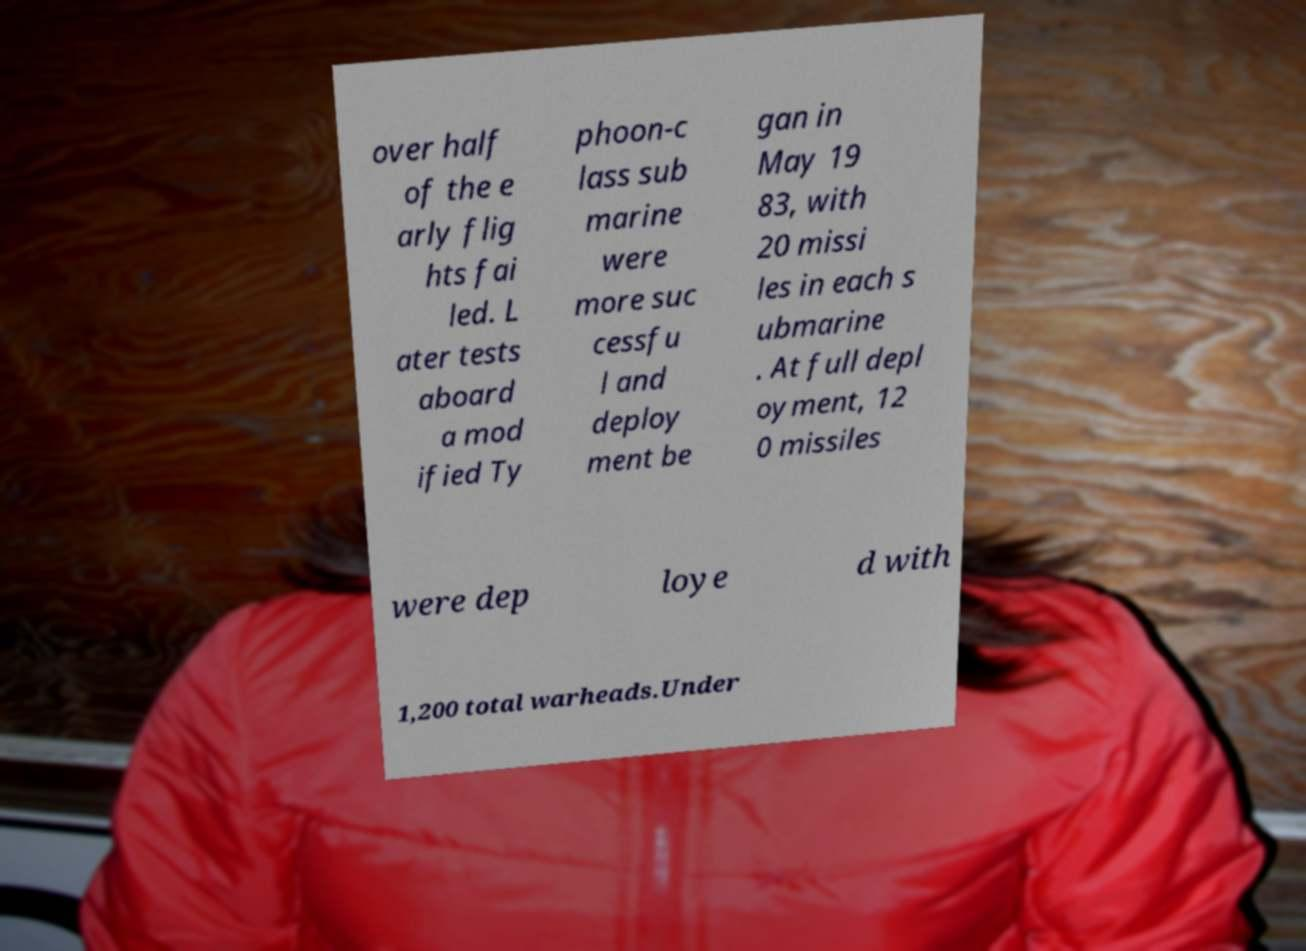For documentation purposes, I need the text within this image transcribed. Could you provide that? over half of the e arly flig hts fai led. L ater tests aboard a mod ified Ty phoon-c lass sub marine were more suc cessfu l and deploy ment be gan in May 19 83, with 20 missi les in each s ubmarine . At full depl oyment, 12 0 missiles were dep loye d with 1,200 total warheads.Under 